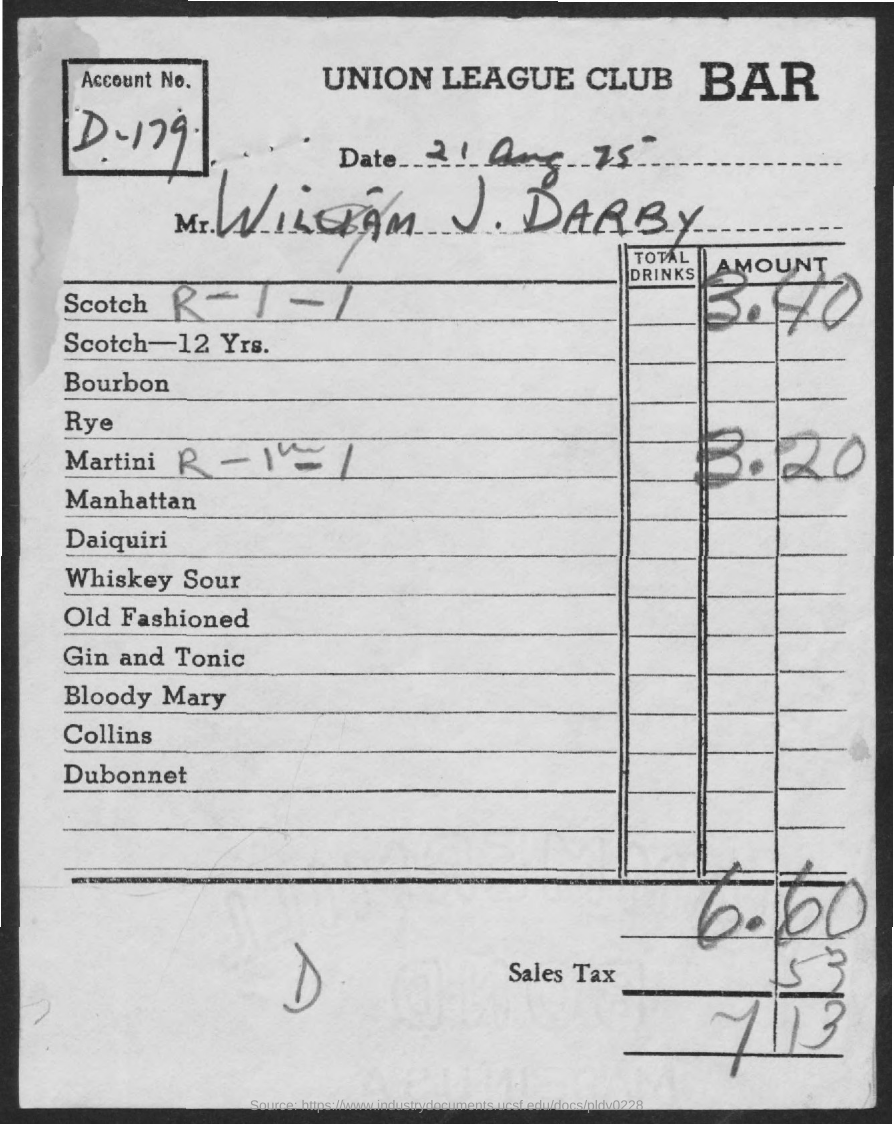What is the date on the document?
Keep it short and to the point. 21 Aug 75. What is the Account No.?
Give a very brief answer. D-179. What is the Name?
Offer a very short reply. William J. Darby. What is the amount for Scotch?
Make the answer very short. 3.40. What is the amount for Martini?
Your response must be concise. 3.20. What is the Tax?
Your answer should be compact. .53. What is the Grand Total?
Your answer should be very brief. 7.13. 